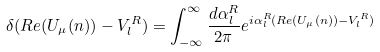Convert formula to latex. <formula><loc_0><loc_0><loc_500><loc_500>\delta ( R e ( U _ { \mu } ( n ) ) - V _ { l } ^ { R } ) = \int _ { - \infty } ^ { \infty } \frac { d \alpha _ { l } ^ { R } } { 2 \pi } e ^ { i \alpha _ { l } ^ { R } ( R e ( U _ { \mu } ( n ) ) - V _ { l } ^ { R } ) }</formula> 